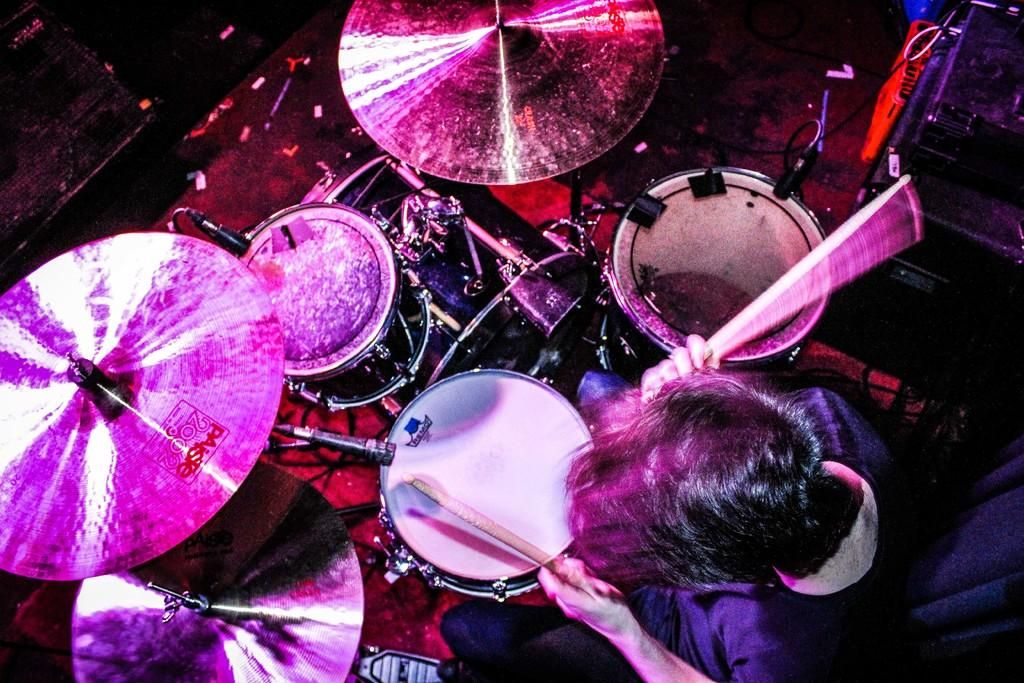What is the person in the image doing? The person is sitting and playing a musical instrument. What type of musical instrument is the person playing? The provided facts do not specify the type of musical instrument. What else can be seen in the image besides the person and the musical instrument? There are additional objects visible in the image. What color is the background of the image? The background of the image is black. Is the person in the image stuck in quicksand? There is no indication of quicksand in the image, and the person is sitting and playing a musical instrument. Can you see any animals from the zoo in the image? There is no mention of a zoo or any animals in the image. 